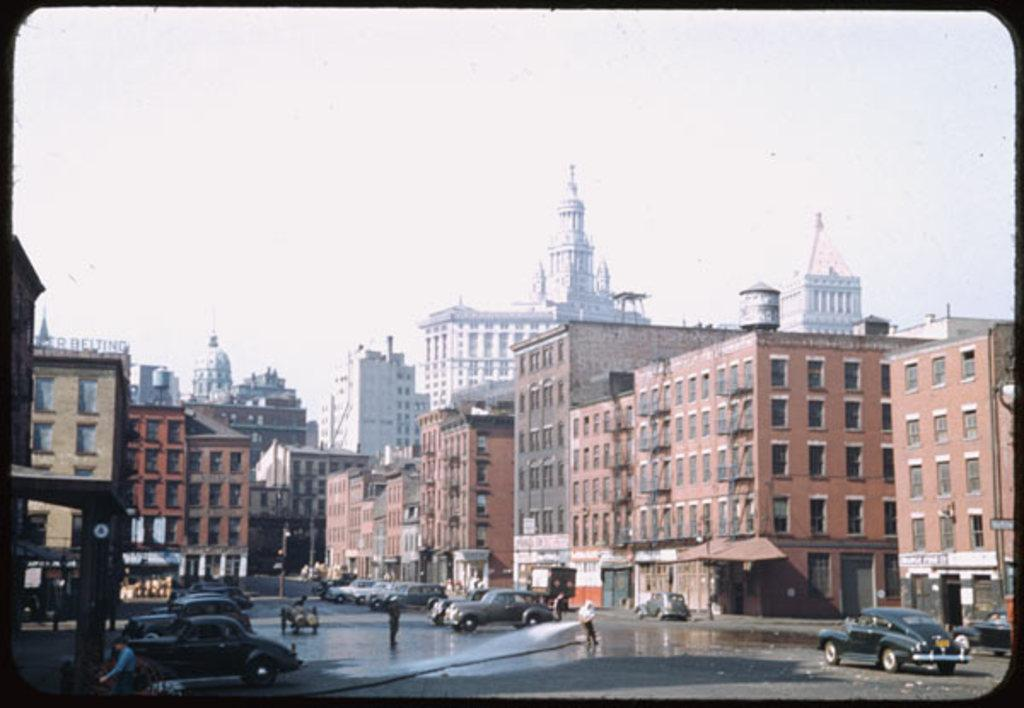What can be seen on the road in the image? There are vehicles on the road in the image. Who or what else is present in the image? There are persons and buildings in the image. Are there any signs or notices visible in the image? Yes, there are boards with text in the image. Can you see any wounds on the persons in the image? There is no mention of any wounds in the provided facts, and therefore we cannot determine if any wounds are present in the image. What type of arch can be seen in the image? There is no mention of an arch in the provided facts, and therefore we cannot determine if any arch is present in the image. 